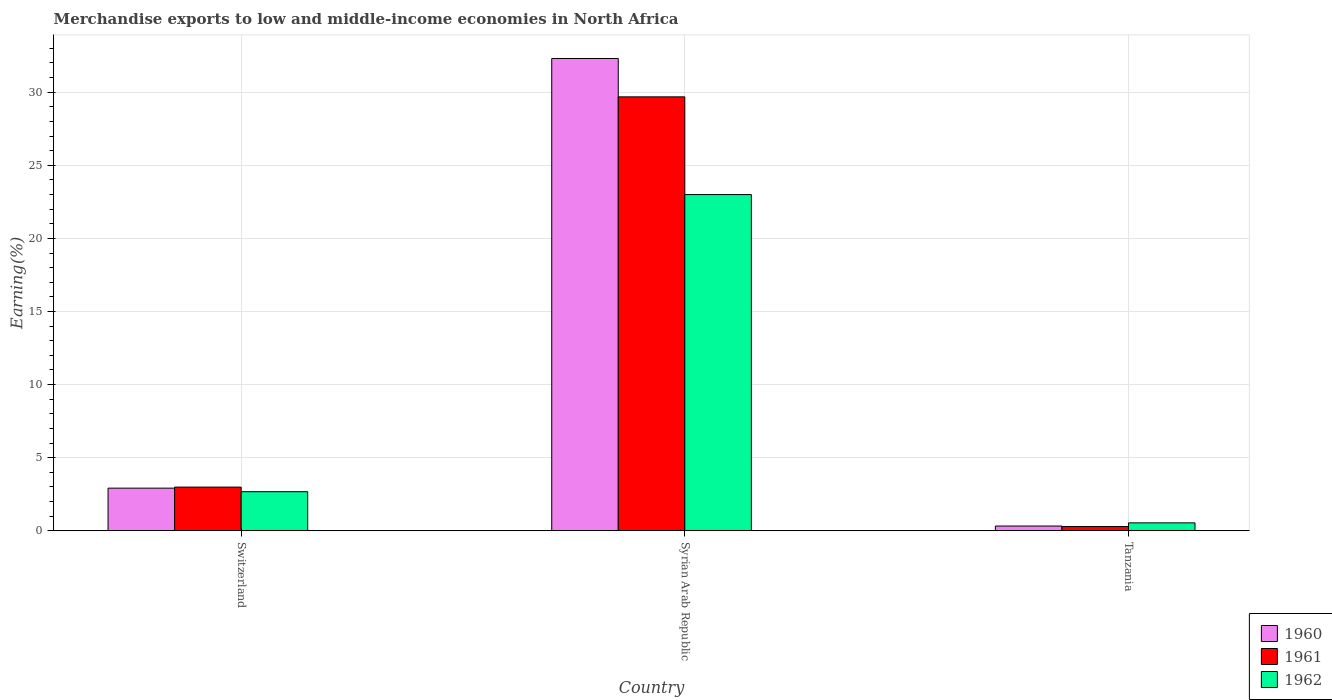How many different coloured bars are there?
Your answer should be very brief. 3. How many groups of bars are there?
Provide a short and direct response. 3. Are the number of bars on each tick of the X-axis equal?
Offer a very short reply. Yes. How many bars are there on the 3rd tick from the right?
Provide a short and direct response. 3. What is the label of the 3rd group of bars from the left?
Your answer should be very brief. Tanzania. In how many cases, is the number of bars for a given country not equal to the number of legend labels?
Your answer should be very brief. 0. What is the percentage of amount earned from merchandise exports in 1962 in Syrian Arab Republic?
Give a very brief answer. 23. Across all countries, what is the maximum percentage of amount earned from merchandise exports in 1960?
Offer a very short reply. 32.31. Across all countries, what is the minimum percentage of amount earned from merchandise exports in 1962?
Give a very brief answer. 0.54. In which country was the percentage of amount earned from merchandise exports in 1960 maximum?
Offer a very short reply. Syrian Arab Republic. In which country was the percentage of amount earned from merchandise exports in 1960 minimum?
Give a very brief answer. Tanzania. What is the total percentage of amount earned from merchandise exports in 1960 in the graph?
Your response must be concise. 35.55. What is the difference between the percentage of amount earned from merchandise exports in 1960 in Switzerland and that in Tanzania?
Offer a very short reply. 2.59. What is the difference between the percentage of amount earned from merchandise exports in 1962 in Tanzania and the percentage of amount earned from merchandise exports in 1960 in Switzerland?
Keep it short and to the point. -2.37. What is the average percentage of amount earned from merchandise exports in 1962 per country?
Offer a very short reply. 8.74. What is the difference between the percentage of amount earned from merchandise exports of/in 1961 and percentage of amount earned from merchandise exports of/in 1960 in Tanzania?
Provide a short and direct response. -0.03. What is the ratio of the percentage of amount earned from merchandise exports in 1961 in Syrian Arab Republic to that in Tanzania?
Your answer should be very brief. 102.56. What is the difference between the highest and the second highest percentage of amount earned from merchandise exports in 1962?
Offer a very short reply. -2.13. What is the difference between the highest and the lowest percentage of amount earned from merchandise exports in 1960?
Ensure brevity in your answer.  31.98. Is the sum of the percentage of amount earned from merchandise exports in 1961 in Switzerland and Syrian Arab Republic greater than the maximum percentage of amount earned from merchandise exports in 1962 across all countries?
Offer a terse response. Yes. Is it the case that in every country, the sum of the percentage of amount earned from merchandise exports in 1960 and percentage of amount earned from merchandise exports in 1961 is greater than the percentage of amount earned from merchandise exports in 1962?
Your answer should be very brief. Yes. Are all the bars in the graph horizontal?
Ensure brevity in your answer.  No. How many countries are there in the graph?
Your answer should be very brief. 3. What is the difference between two consecutive major ticks on the Y-axis?
Keep it short and to the point. 5. Are the values on the major ticks of Y-axis written in scientific E-notation?
Provide a short and direct response. No. Does the graph contain any zero values?
Provide a short and direct response. No. Does the graph contain grids?
Offer a terse response. Yes. How are the legend labels stacked?
Provide a succinct answer. Vertical. What is the title of the graph?
Offer a very short reply. Merchandise exports to low and middle-income economies in North Africa. What is the label or title of the X-axis?
Keep it short and to the point. Country. What is the label or title of the Y-axis?
Your answer should be very brief. Earning(%). What is the Earning(%) in 1960 in Switzerland?
Ensure brevity in your answer.  2.92. What is the Earning(%) of 1961 in Switzerland?
Your response must be concise. 2.99. What is the Earning(%) in 1962 in Switzerland?
Your answer should be very brief. 2.67. What is the Earning(%) in 1960 in Syrian Arab Republic?
Provide a succinct answer. 32.31. What is the Earning(%) of 1961 in Syrian Arab Republic?
Keep it short and to the point. 29.68. What is the Earning(%) in 1962 in Syrian Arab Republic?
Keep it short and to the point. 23. What is the Earning(%) in 1960 in Tanzania?
Offer a very short reply. 0.32. What is the Earning(%) in 1961 in Tanzania?
Make the answer very short. 0.29. What is the Earning(%) in 1962 in Tanzania?
Your answer should be very brief. 0.54. Across all countries, what is the maximum Earning(%) of 1960?
Keep it short and to the point. 32.31. Across all countries, what is the maximum Earning(%) of 1961?
Your answer should be very brief. 29.68. Across all countries, what is the maximum Earning(%) of 1962?
Your answer should be very brief. 23. Across all countries, what is the minimum Earning(%) in 1960?
Your answer should be very brief. 0.32. Across all countries, what is the minimum Earning(%) in 1961?
Ensure brevity in your answer.  0.29. Across all countries, what is the minimum Earning(%) of 1962?
Make the answer very short. 0.54. What is the total Earning(%) of 1960 in the graph?
Ensure brevity in your answer.  35.55. What is the total Earning(%) in 1961 in the graph?
Offer a very short reply. 32.96. What is the total Earning(%) in 1962 in the graph?
Make the answer very short. 26.22. What is the difference between the Earning(%) of 1960 in Switzerland and that in Syrian Arab Republic?
Ensure brevity in your answer.  -29.39. What is the difference between the Earning(%) of 1961 in Switzerland and that in Syrian Arab Republic?
Ensure brevity in your answer.  -26.69. What is the difference between the Earning(%) in 1962 in Switzerland and that in Syrian Arab Republic?
Ensure brevity in your answer.  -20.32. What is the difference between the Earning(%) of 1960 in Switzerland and that in Tanzania?
Ensure brevity in your answer.  2.59. What is the difference between the Earning(%) of 1961 in Switzerland and that in Tanzania?
Keep it short and to the point. 2.7. What is the difference between the Earning(%) in 1962 in Switzerland and that in Tanzania?
Make the answer very short. 2.13. What is the difference between the Earning(%) in 1960 in Syrian Arab Republic and that in Tanzania?
Your answer should be very brief. 31.98. What is the difference between the Earning(%) of 1961 in Syrian Arab Republic and that in Tanzania?
Give a very brief answer. 29.39. What is the difference between the Earning(%) in 1962 in Syrian Arab Republic and that in Tanzania?
Keep it short and to the point. 22.46. What is the difference between the Earning(%) in 1960 in Switzerland and the Earning(%) in 1961 in Syrian Arab Republic?
Your answer should be compact. -26.77. What is the difference between the Earning(%) of 1960 in Switzerland and the Earning(%) of 1962 in Syrian Arab Republic?
Provide a short and direct response. -20.08. What is the difference between the Earning(%) in 1961 in Switzerland and the Earning(%) in 1962 in Syrian Arab Republic?
Your response must be concise. -20.01. What is the difference between the Earning(%) in 1960 in Switzerland and the Earning(%) in 1961 in Tanzania?
Provide a succinct answer. 2.63. What is the difference between the Earning(%) in 1960 in Switzerland and the Earning(%) in 1962 in Tanzania?
Your answer should be compact. 2.37. What is the difference between the Earning(%) in 1961 in Switzerland and the Earning(%) in 1962 in Tanzania?
Give a very brief answer. 2.45. What is the difference between the Earning(%) in 1960 in Syrian Arab Republic and the Earning(%) in 1961 in Tanzania?
Make the answer very short. 32.02. What is the difference between the Earning(%) in 1960 in Syrian Arab Republic and the Earning(%) in 1962 in Tanzania?
Offer a very short reply. 31.77. What is the difference between the Earning(%) of 1961 in Syrian Arab Republic and the Earning(%) of 1962 in Tanzania?
Your response must be concise. 29.14. What is the average Earning(%) in 1960 per country?
Offer a very short reply. 11.85. What is the average Earning(%) in 1961 per country?
Your response must be concise. 10.99. What is the average Earning(%) of 1962 per country?
Offer a very short reply. 8.74. What is the difference between the Earning(%) of 1960 and Earning(%) of 1961 in Switzerland?
Keep it short and to the point. -0.07. What is the difference between the Earning(%) of 1960 and Earning(%) of 1962 in Switzerland?
Make the answer very short. 0.24. What is the difference between the Earning(%) of 1961 and Earning(%) of 1962 in Switzerland?
Provide a short and direct response. 0.31. What is the difference between the Earning(%) of 1960 and Earning(%) of 1961 in Syrian Arab Republic?
Offer a very short reply. 2.62. What is the difference between the Earning(%) in 1960 and Earning(%) in 1962 in Syrian Arab Republic?
Your answer should be compact. 9.31. What is the difference between the Earning(%) in 1961 and Earning(%) in 1962 in Syrian Arab Republic?
Ensure brevity in your answer.  6.68. What is the difference between the Earning(%) in 1960 and Earning(%) in 1961 in Tanzania?
Provide a short and direct response. 0.03. What is the difference between the Earning(%) of 1960 and Earning(%) of 1962 in Tanzania?
Offer a terse response. -0.22. What is the difference between the Earning(%) of 1961 and Earning(%) of 1962 in Tanzania?
Offer a terse response. -0.25. What is the ratio of the Earning(%) in 1960 in Switzerland to that in Syrian Arab Republic?
Your answer should be compact. 0.09. What is the ratio of the Earning(%) in 1961 in Switzerland to that in Syrian Arab Republic?
Offer a very short reply. 0.1. What is the ratio of the Earning(%) in 1962 in Switzerland to that in Syrian Arab Republic?
Give a very brief answer. 0.12. What is the ratio of the Earning(%) of 1960 in Switzerland to that in Tanzania?
Give a very brief answer. 9. What is the ratio of the Earning(%) in 1961 in Switzerland to that in Tanzania?
Give a very brief answer. 10.33. What is the ratio of the Earning(%) in 1962 in Switzerland to that in Tanzania?
Keep it short and to the point. 4.93. What is the ratio of the Earning(%) in 1960 in Syrian Arab Republic to that in Tanzania?
Offer a terse response. 99.64. What is the ratio of the Earning(%) of 1961 in Syrian Arab Republic to that in Tanzania?
Keep it short and to the point. 102.56. What is the ratio of the Earning(%) of 1962 in Syrian Arab Republic to that in Tanzania?
Make the answer very short. 42.38. What is the difference between the highest and the second highest Earning(%) in 1960?
Give a very brief answer. 29.39. What is the difference between the highest and the second highest Earning(%) of 1961?
Your answer should be very brief. 26.69. What is the difference between the highest and the second highest Earning(%) of 1962?
Keep it short and to the point. 20.32. What is the difference between the highest and the lowest Earning(%) of 1960?
Your answer should be very brief. 31.98. What is the difference between the highest and the lowest Earning(%) of 1961?
Provide a succinct answer. 29.39. What is the difference between the highest and the lowest Earning(%) of 1962?
Your answer should be compact. 22.46. 